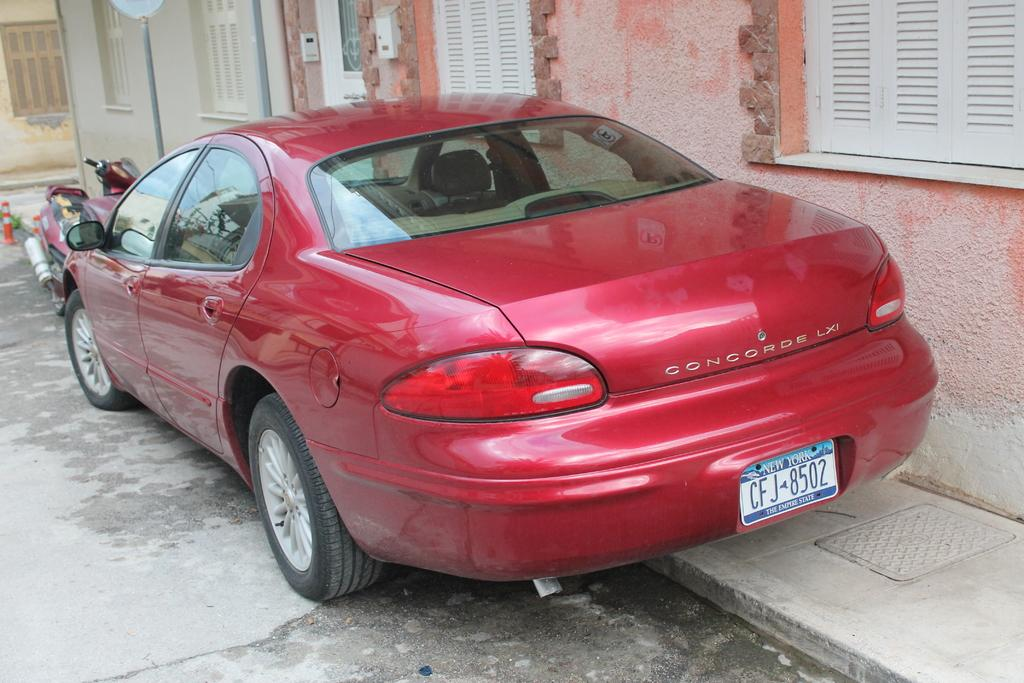<image>
Present a compact description of the photo's key features. A red car called a CONCORDE LXI from New York. 